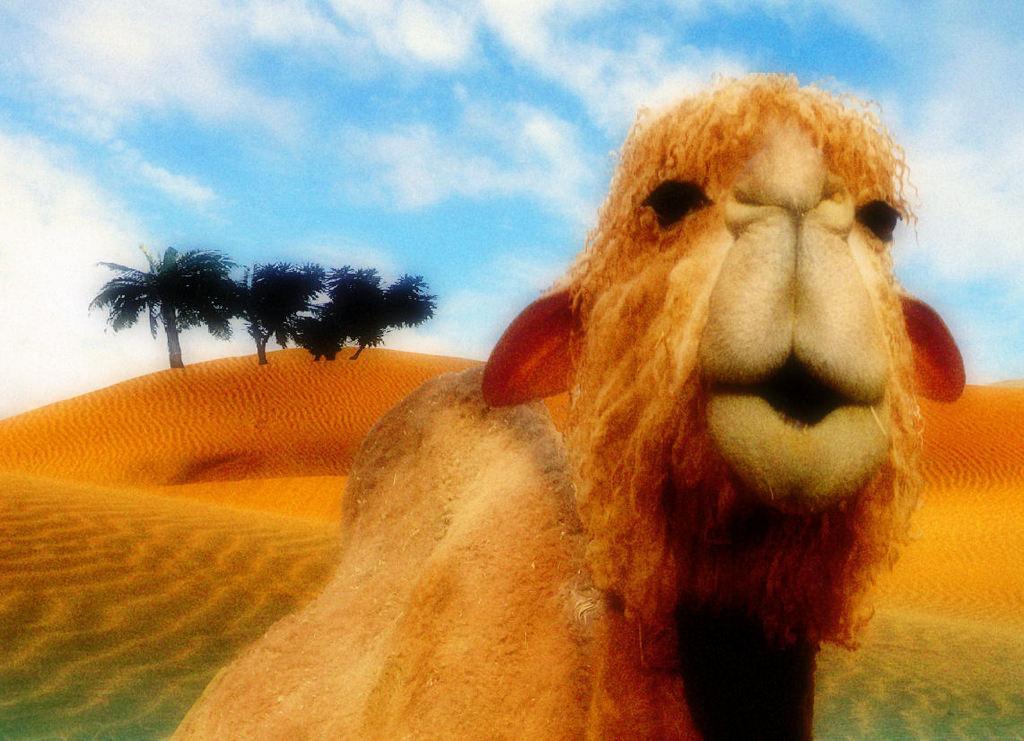Please provide a concise description of this image. Here we can see an animal. Far there are trees. Sky is cloudy. 